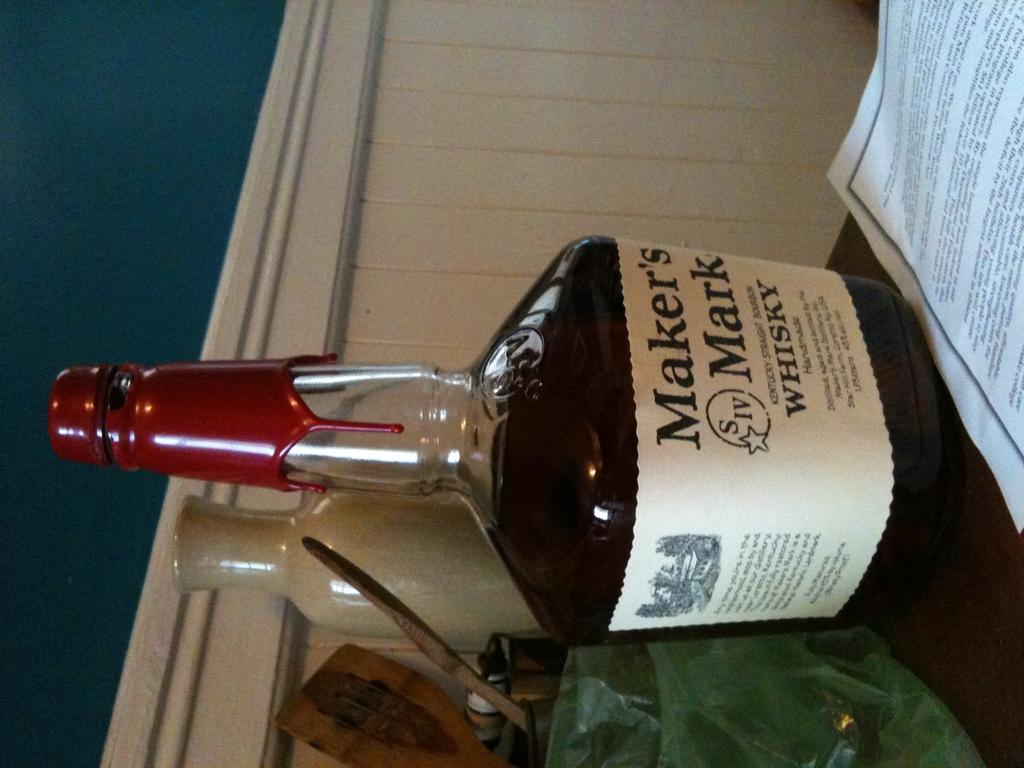What kind of alcohol is in the bottle?
Provide a succinct answer. Whisky. What is the name brand on the bottle?
Your response must be concise. Maker's mark. 